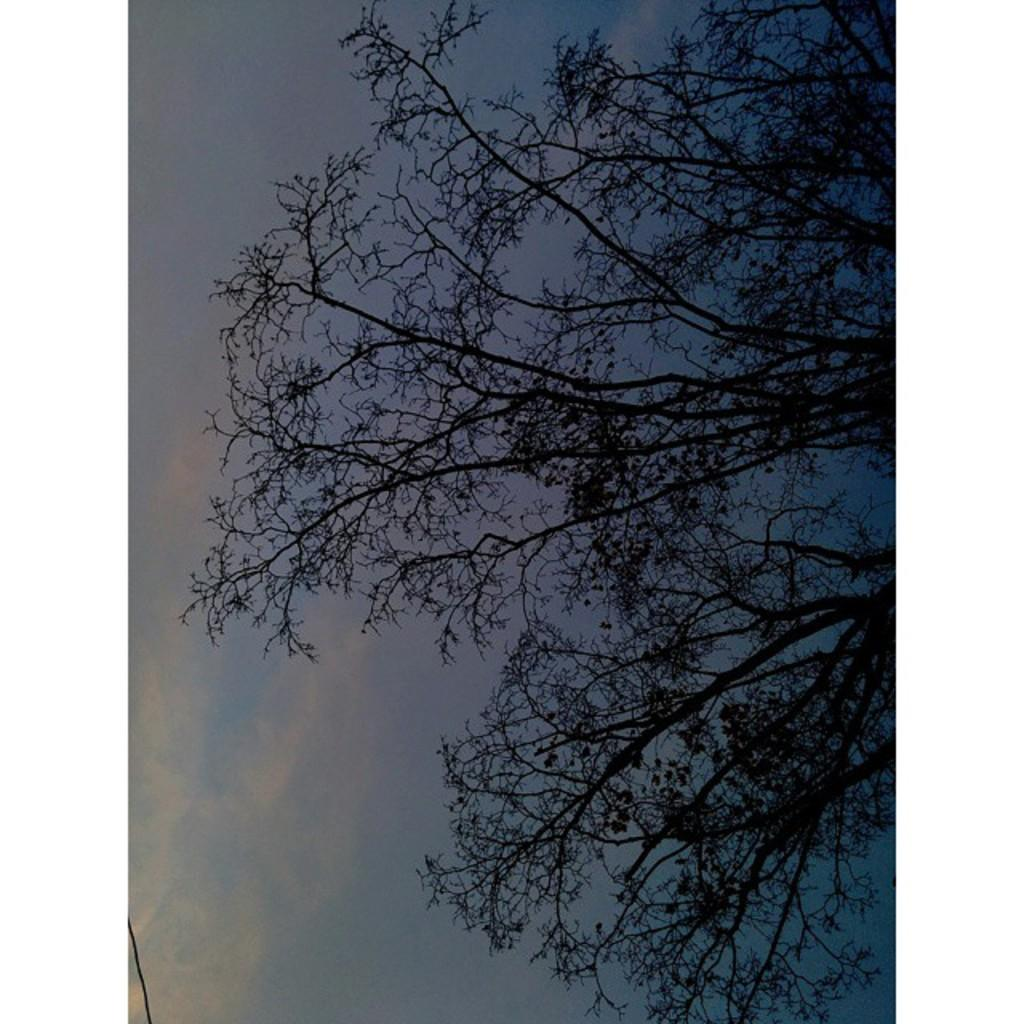What natural element is present in the image? There is a tree in the image. What part of the sky can be seen in the image? The sky and clouds are visible on the left side of the image. Is there any man-made object present in the image? Yes, there is a wire in the bottom left corner of the image. How is the bait being used on the tree in the image? There is no bait present in the image; it only features a tree, sky, clouds, and a wire. What type of tray is visible on the tree in the image? There is no tray present on the tree in the image. 